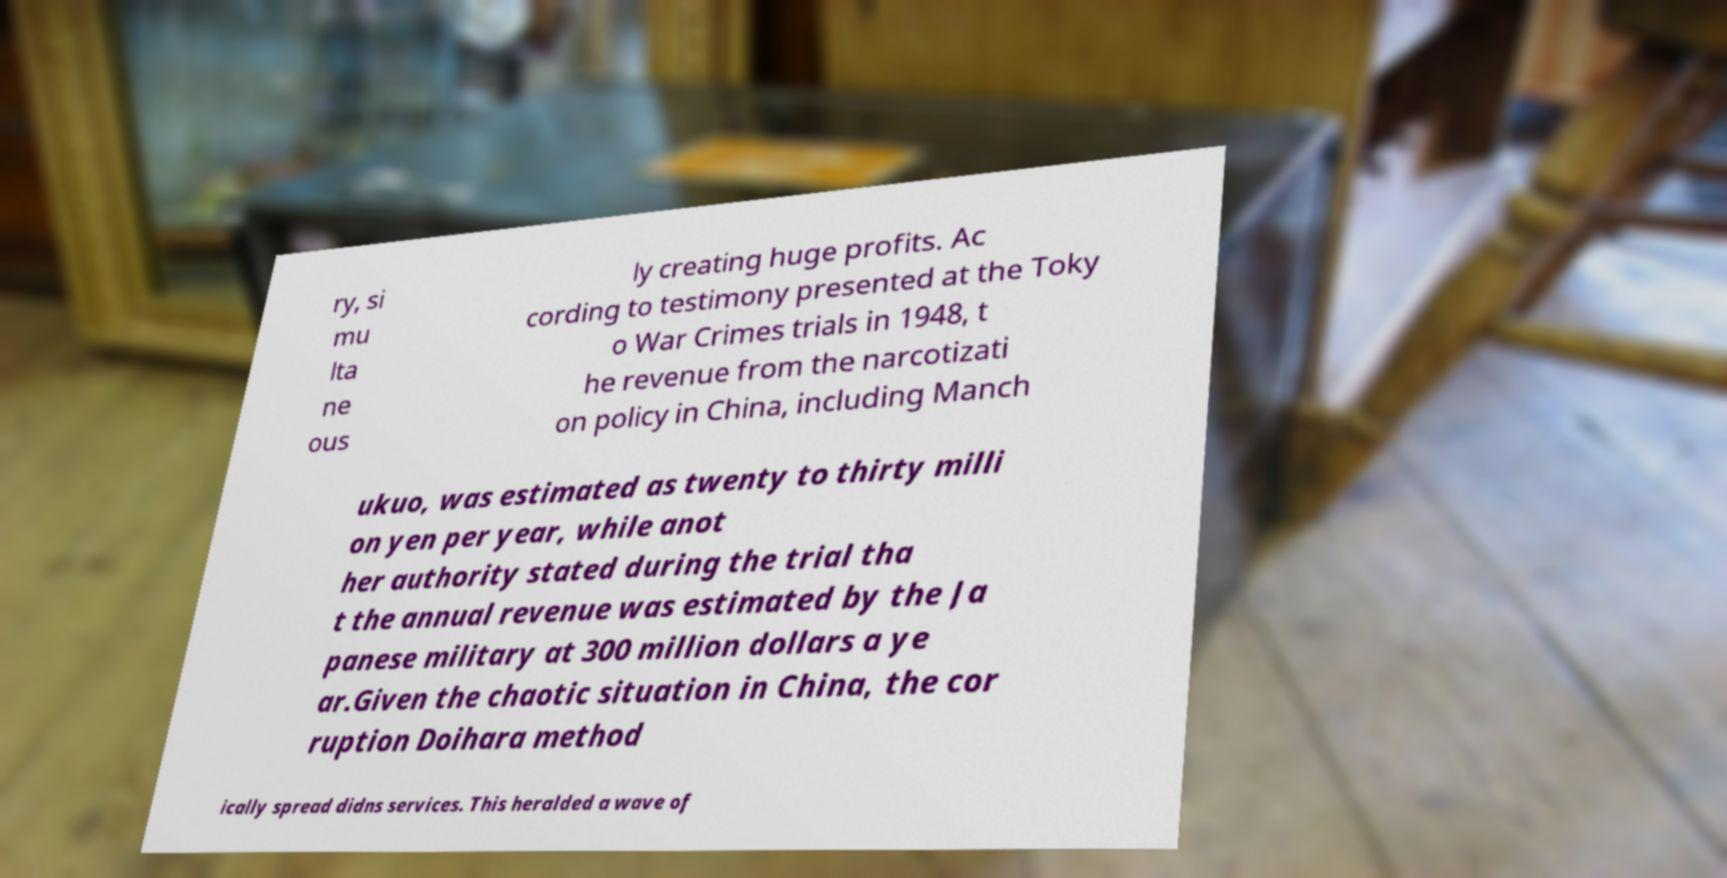Please read and relay the text visible in this image. What does it say? ry, si mu lta ne ous ly creating huge profits. Ac cording to testimony presented at the Toky o War Crimes trials in 1948, t he revenue from the narcotizati on policy in China, including Manch ukuo, was estimated as twenty to thirty milli on yen per year, while anot her authority stated during the trial tha t the annual revenue was estimated by the Ja panese military at 300 million dollars a ye ar.Given the chaotic situation in China, the cor ruption Doihara method ically spread didns services. This heralded a wave of 